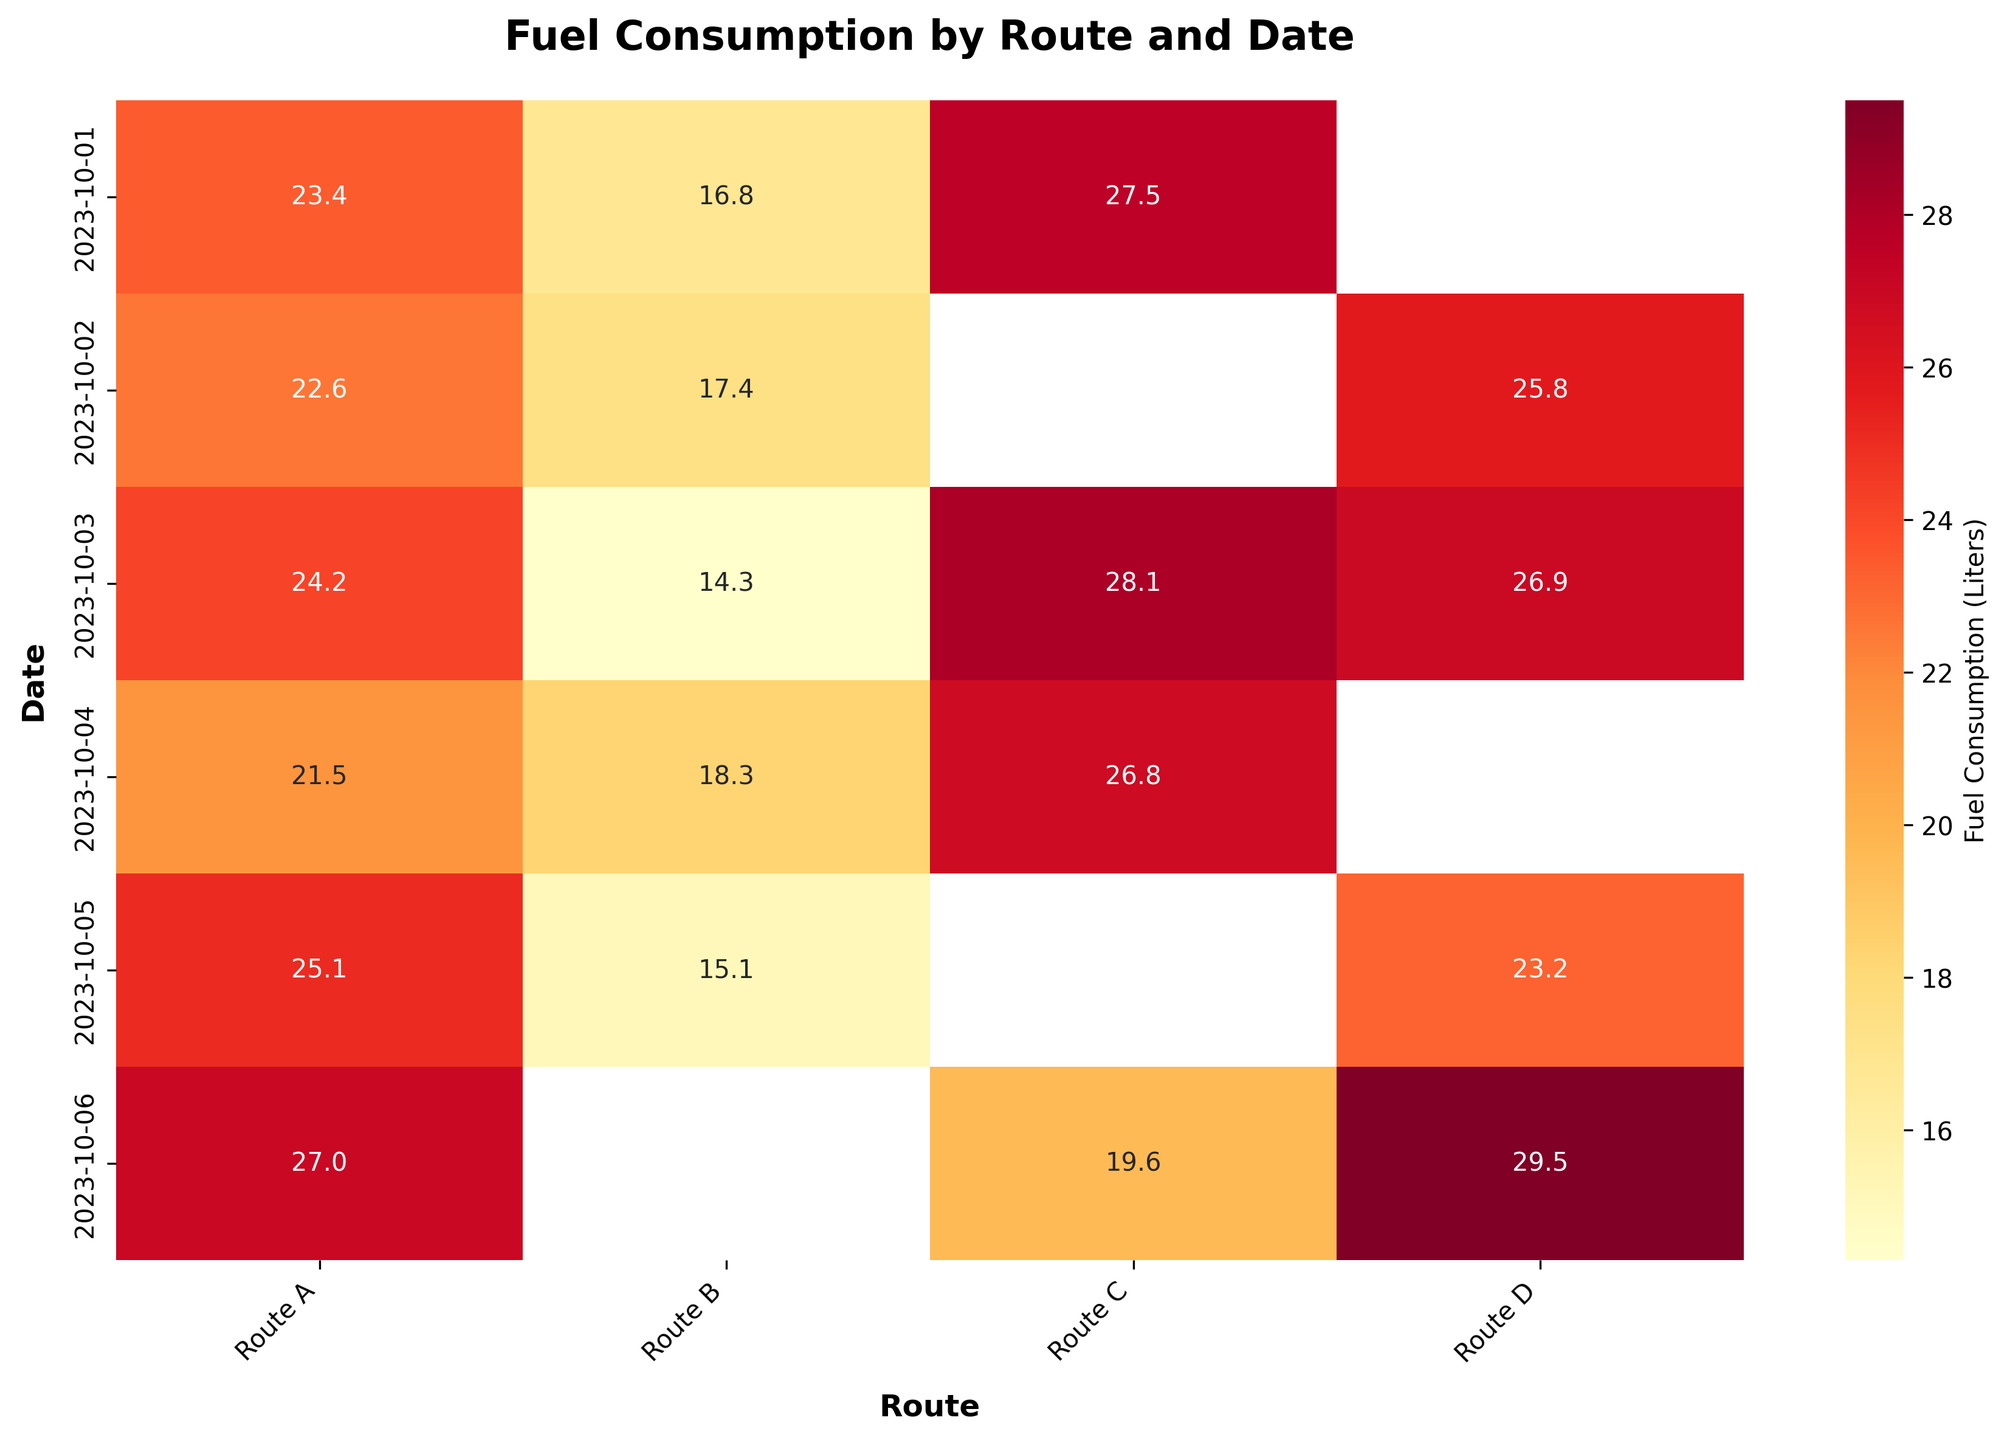What's the title of the heatmap? The title of a plot is usually displayed at the top of the figure. For this heatmap, it clearly states the main focus of the visualization.
Answer: Fuel Consumption by Route and Date Which route shows the highest fuel consumption on 2023-10-01? On 2023-10-01, you can scan across the rows associated with that date to identify the highest value.
Answer: Route C What is the total fuel consumption for Route A over the given dates? Add the fuel consumption values for Route A: 23.4 + 22.6 + 24.2 + 21.5 + 25.1 + 27.0.
Answer: 143.8 liters Which date had the highest fuel consumption overall? Summing the fuel consumption for all routes on each date and then comparing these sums reveals the highest. Adding all values for each date and identifying the maximum sum (e.g., 2023-10-06: 27.0 + 19.6 + 29.5).
Answer: 2023-10-06 On which route and date combination was the fuel consumption the lowest? By comparing all the values in the heatmap and identifying the smallest number present, you find the lowest fuel consumption point.
Answer: 2023-10-03, Route B How does the fuel consumption on Route B compare between 2023-10-02 and 2023-10-03? Locate the fuel consumption values for Route B on the dates 2023-10-02 (17.4) and 2023-10-03 (14.3) and perform a comparison.
Answer: 2023-10-02 is higher What is the average fuel consumption for Route D? Sum the fuel consumption values for Route D and divide by the number of entries: (25.8 + 26.9 + 23.2 + 29.5) / 4.
Answer: 25.85 liters Which route has the highest average fuel consumption? Calculate the average fuel consumption for each route by summing the values and dividing by the number of data points, then compare these averages. For example: Route C average = (27.5 + 28.1 + 26.8 + 19.6) / 4.
Answer: Route C Is there any missing data for any routes on any dates? By checking the heatmap, missing data is represented by blank spaces or 'NaN' values.
Answer: Yes Which route consistently shows the lowest fuel consumption across all dates? By looking at each route's values across all dates and identifying the one with the consistently lower values, you find the route. In this case, sum each row and compare.
Answer: Route B 